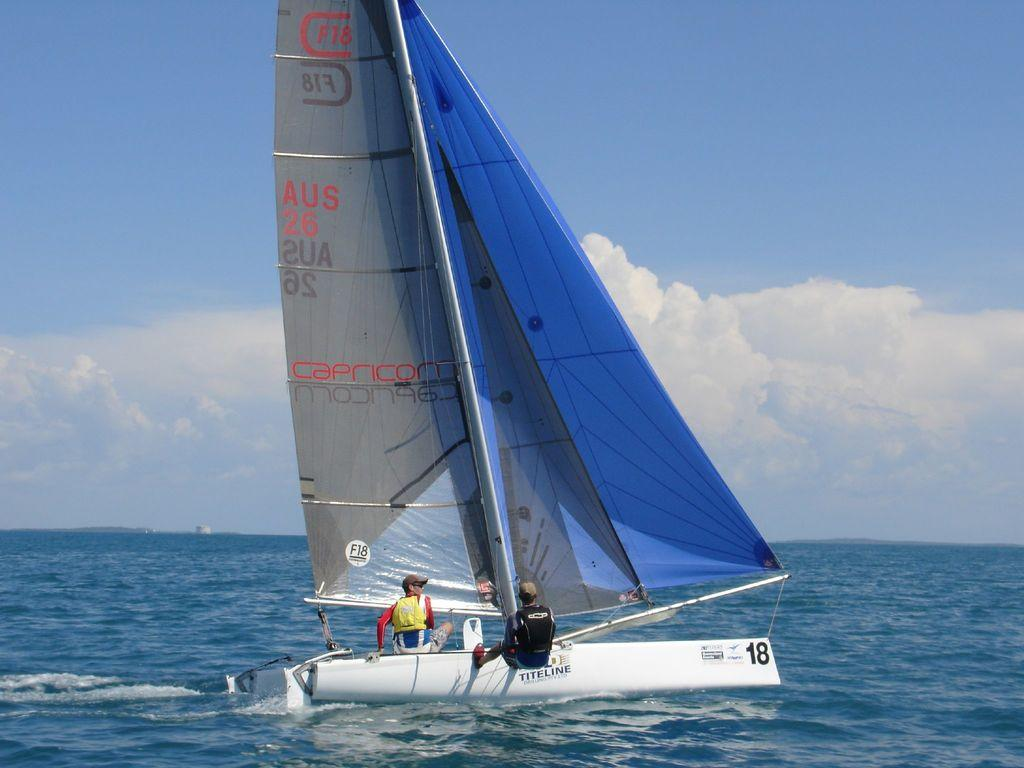How many people are in the image? There are two people in the image. What are the two people doing in the image? The two people are on a boat. What is visible in the background of the image? There is water and sky visible in the image. What can be seen in the sky? There are clouds in the sky. What type of silk is being used to cover the cemetery in the image? There is no silk or cemetery present in the image. The image features two people on a boat with water and sky visible in the background. 